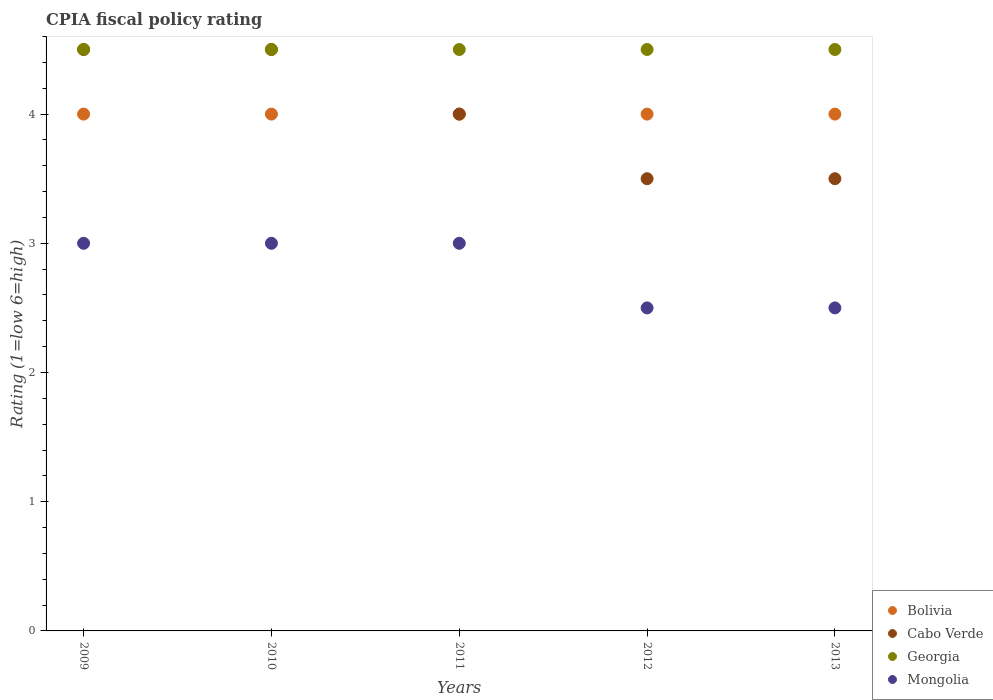How many different coloured dotlines are there?
Ensure brevity in your answer.  4. Is the number of dotlines equal to the number of legend labels?
Ensure brevity in your answer.  Yes. What is the CPIA rating in Cabo Verde in 2009?
Give a very brief answer. 4.5. Across all years, what is the minimum CPIA rating in Bolivia?
Provide a succinct answer. 4. What is the difference between the CPIA rating in Georgia in 2011 and that in 2012?
Make the answer very short. 0. What is the difference between the CPIA rating in Cabo Verde in 2010 and the CPIA rating in Bolivia in 2012?
Provide a short and direct response. 0.5. What is the average CPIA rating in Cabo Verde per year?
Keep it short and to the point. 4. What is the ratio of the CPIA rating in Georgia in 2009 to that in 2010?
Provide a short and direct response. 1. Is the sum of the CPIA rating in Bolivia in 2009 and 2013 greater than the maximum CPIA rating in Mongolia across all years?
Your answer should be very brief. Yes. Is it the case that in every year, the sum of the CPIA rating in Bolivia and CPIA rating in Georgia  is greater than the sum of CPIA rating in Mongolia and CPIA rating in Cabo Verde?
Ensure brevity in your answer.  Yes. Is it the case that in every year, the sum of the CPIA rating in Georgia and CPIA rating in Mongolia  is greater than the CPIA rating in Bolivia?
Provide a succinct answer. Yes. Is the CPIA rating in Mongolia strictly greater than the CPIA rating in Bolivia over the years?
Provide a succinct answer. No. How many years are there in the graph?
Offer a terse response. 5. What is the difference between two consecutive major ticks on the Y-axis?
Offer a terse response. 1. What is the title of the graph?
Keep it short and to the point. CPIA fiscal policy rating. What is the label or title of the X-axis?
Keep it short and to the point. Years. What is the Rating (1=low 6=high) of Cabo Verde in 2009?
Give a very brief answer. 4.5. What is the Rating (1=low 6=high) of Mongolia in 2009?
Ensure brevity in your answer.  3. What is the Rating (1=low 6=high) of Georgia in 2010?
Provide a short and direct response. 4.5. What is the Rating (1=low 6=high) in Mongolia in 2010?
Give a very brief answer. 3. What is the Rating (1=low 6=high) in Cabo Verde in 2011?
Offer a very short reply. 4. What is the Rating (1=low 6=high) of Georgia in 2011?
Make the answer very short. 4.5. What is the Rating (1=low 6=high) of Mongolia in 2012?
Your response must be concise. 2.5. Across all years, what is the maximum Rating (1=low 6=high) in Georgia?
Give a very brief answer. 4.5. Across all years, what is the maximum Rating (1=low 6=high) in Mongolia?
Make the answer very short. 3. Across all years, what is the minimum Rating (1=low 6=high) in Georgia?
Your answer should be very brief. 4.5. What is the total Rating (1=low 6=high) of Cabo Verde in the graph?
Your answer should be compact. 20. What is the total Rating (1=low 6=high) in Georgia in the graph?
Your answer should be very brief. 22.5. What is the difference between the Rating (1=low 6=high) of Bolivia in 2009 and that in 2010?
Make the answer very short. 0. What is the difference between the Rating (1=low 6=high) of Georgia in 2009 and that in 2010?
Offer a terse response. 0. What is the difference between the Rating (1=low 6=high) of Mongolia in 2009 and that in 2010?
Provide a succinct answer. 0. What is the difference between the Rating (1=low 6=high) in Georgia in 2009 and that in 2011?
Your answer should be compact. 0. What is the difference between the Rating (1=low 6=high) of Mongolia in 2009 and that in 2011?
Give a very brief answer. 0. What is the difference between the Rating (1=low 6=high) of Cabo Verde in 2009 and that in 2012?
Provide a short and direct response. 1. What is the difference between the Rating (1=low 6=high) of Bolivia in 2009 and that in 2013?
Offer a terse response. 0. What is the difference between the Rating (1=low 6=high) of Mongolia in 2009 and that in 2013?
Your answer should be compact. 0.5. What is the difference between the Rating (1=low 6=high) in Cabo Verde in 2010 and that in 2011?
Keep it short and to the point. 0.5. What is the difference between the Rating (1=low 6=high) in Mongolia in 2010 and that in 2011?
Offer a very short reply. 0. What is the difference between the Rating (1=low 6=high) of Bolivia in 2010 and that in 2012?
Ensure brevity in your answer.  0. What is the difference between the Rating (1=low 6=high) of Cabo Verde in 2010 and that in 2012?
Your answer should be very brief. 1. What is the difference between the Rating (1=low 6=high) in Georgia in 2010 and that in 2012?
Ensure brevity in your answer.  0. What is the difference between the Rating (1=low 6=high) in Georgia in 2010 and that in 2013?
Provide a succinct answer. 0. What is the difference between the Rating (1=low 6=high) of Georgia in 2011 and that in 2012?
Your answer should be compact. 0. What is the difference between the Rating (1=low 6=high) in Mongolia in 2011 and that in 2012?
Keep it short and to the point. 0.5. What is the difference between the Rating (1=low 6=high) in Bolivia in 2011 and that in 2013?
Give a very brief answer. 0. What is the difference between the Rating (1=low 6=high) in Cabo Verde in 2011 and that in 2013?
Offer a terse response. 0.5. What is the difference between the Rating (1=low 6=high) of Cabo Verde in 2012 and that in 2013?
Make the answer very short. 0. What is the difference between the Rating (1=low 6=high) of Cabo Verde in 2009 and the Rating (1=low 6=high) of Georgia in 2010?
Your answer should be very brief. 0. What is the difference between the Rating (1=low 6=high) in Cabo Verde in 2009 and the Rating (1=low 6=high) in Mongolia in 2010?
Offer a terse response. 1.5. What is the difference between the Rating (1=low 6=high) of Georgia in 2009 and the Rating (1=low 6=high) of Mongolia in 2010?
Provide a short and direct response. 1.5. What is the difference between the Rating (1=low 6=high) in Bolivia in 2009 and the Rating (1=low 6=high) in Cabo Verde in 2011?
Your answer should be compact. 0. What is the difference between the Rating (1=low 6=high) of Bolivia in 2009 and the Rating (1=low 6=high) of Georgia in 2011?
Ensure brevity in your answer.  -0.5. What is the difference between the Rating (1=low 6=high) in Cabo Verde in 2009 and the Rating (1=low 6=high) in Georgia in 2011?
Your answer should be compact. 0. What is the difference between the Rating (1=low 6=high) in Georgia in 2009 and the Rating (1=low 6=high) in Mongolia in 2011?
Offer a terse response. 1.5. What is the difference between the Rating (1=low 6=high) in Bolivia in 2009 and the Rating (1=low 6=high) in Georgia in 2012?
Your response must be concise. -0.5. What is the difference between the Rating (1=low 6=high) of Bolivia in 2009 and the Rating (1=low 6=high) of Mongolia in 2012?
Provide a short and direct response. 1.5. What is the difference between the Rating (1=low 6=high) of Cabo Verde in 2009 and the Rating (1=low 6=high) of Mongolia in 2012?
Your answer should be compact. 2. What is the difference between the Rating (1=low 6=high) of Bolivia in 2009 and the Rating (1=low 6=high) of Cabo Verde in 2013?
Provide a succinct answer. 0.5. What is the difference between the Rating (1=low 6=high) in Bolivia in 2009 and the Rating (1=low 6=high) in Georgia in 2013?
Offer a terse response. -0.5. What is the difference between the Rating (1=low 6=high) in Cabo Verde in 2009 and the Rating (1=low 6=high) in Georgia in 2013?
Your answer should be compact. 0. What is the difference between the Rating (1=low 6=high) in Bolivia in 2010 and the Rating (1=low 6=high) in Cabo Verde in 2011?
Ensure brevity in your answer.  0. What is the difference between the Rating (1=low 6=high) of Bolivia in 2010 and the Rating (1=low 6=high) of Georgia in 2011?
Keep it short and to the point. -0.5. What is the difference between the Rating (1=low 6=high) of Bolivia in 2010 and the Rating (1=low 6=high) of Mongolia in 2011?
Give a very brief answer. 1. What is the difference between the Rating (1=low 6=high) of Cabo Verde in 2010 and the Rating (1=low 6=high) of Georgia in 2011?
Ensure brevity in your answer.  0. What is the difference between the Rating (1=low 6=high) of Bolivia in 2010 and the Rating (1=low 6=high) of Cabo Verde in 2012?
Provide a short and direct response. 0.5. What is the difference between the Rating (1=low 6=high) in Bolivia in 2010 and the Rating (1=low 6=high) in Georgia in 2012?
Offer a terse response. -0.5. What is the difference between the Rating (1=low 6=high) of Cabo Verde in 2010 and the Rating (1=low 6=high) of Georgia in 2012?
Make the answer very short. 0. What is the difference between the Rating (1=low 6=high) in Cabo Verde in 2010 and the Rating (1=low 6=high) in Mongolia in 2012?
Your answer should be very brief. 2. What is the difference between the Rating (1=low 6=high) in Bolivia in 2010 and the Rating (1=low 6=high) in Cabo Verde in 2013?
Give a very brief answer. 0.5. What is the difference between the Rating (1=low 6=high) of Bolivia in 2010 and the Rating (1=low 6=high) of Georgia in 2013?
Make the answer very short. -0.5. What is the difference between the Rating (1=low 6=high) of Cabo Verde in 2010 and the Rating (1=low 6=high) of Georgia in 2013?
Your answer should be compact. 0. What is the difference between the Rating (1=low 6=high) in Georgia in 2010 and the Rating (1=low 6=high) in Mongolia in 2013?
Provide a succinct answer. 2. What is the difference between the Rating (1=low 6=high) in Bolivia in 2011 and the Rating (1=low 6=high) in Cabo Verde in 2012?
Offer a very short reply. 0.5. What is the difference between the Rating (1=low 6=high) in Bolivia in 2011 and the Rating (1=low 6=high) in Georgia in 2012?
Offer a very short reply. -0.5. What is the difference between the Rating (1=low 6=high) in Cabo Verde in 2011 and the Rating (1=low 6=high) in Georgia in 2012?
Provide a succinct answer. -0.5. What is the difference between the Rating (1=low 6=high) in Georgia in 2011 and the Rating (1=low 6=high) in Mongolia in 2013?
Make the answer very short. 2. What is the difference between the Rating (1=low 6=high) in Bolivia in 2012 and the Rating (1=low 6=high) in Georgia in 2013?
Your answer should be very brief. -0.5. What is the difference between the Rating (1=low 6=high) of Cabo Verde in 2012 and the Rating (1=low 6=high) of Georgia in 2013?
Offer a very short reply. -1. What is the difference between the Rating (1=low 6=high) in Georgia in 2012 and the Rating (1=low 6=high) in Mongolia in 2013?
Offer a very short reply. 2. What is the average Rating (1=low 6=high) in Bolivia per year?
Your answer should be very brief. 4. What is the average Rating (1=low 6=high) in Georgia per year?
Keep it short and to the point. 4.5. In the year 2009, what is the difference between the Rating (1=low 6=high) of Bolivia and Rating (1=low 6=high) of Mongolia?
Your response must be concise. 1. In the year 2009, what is the difference between the Rating (1=low 6=high) in Cabo Verde and Rating (1=low 6=high) in Mongolia?
Offer a terse response. 1.5. In the year 2009, what is the difference between the Rating (1=low 6=high) of Georgia and Rating (1=low 6=high) of Mongolia?
Provide a short and direct response. 1.5. In the year 2010, what is the difference between the Rating (1=low 6=high) of Bolivia and Rating (1=low 6=high) of Cabo Verde?
Make the answer very short. -0.5. In the year 2010, what is the difference between the Rating (1=low 6=high) in Bolivia and Rating (1=low 6=high) in Georgia?
Your response must be concise. -0.5. In the year 2010, what is the difference between the Rating (1=low 6=high) in Cabo Verde and Rating (1=low 6=high) in Mongolia?
Provide a succinct answer. 1.5. In the year 2011, what is the difference between the Rating (1=low 6=high) of Bolivia and Rating (1=low 6=high) of Cabo Verde?
Provide a short and direct response. 0. In the year 2011, what is the difference between the Rating (1=low 6=high) of Bolivia and Rating (1=low 6=high) of Georgia?
Ensure brevity in your answer.  -0.5. In the year 2011, what is the difference between the Rating (1=low 6=high) of Bolivia and Rating (1=low 6=high) of Mongolia?
Make the answer very short. 1. In the year 2011, what is the difference between the Rating (1=low 6=high) in Cabo Verde and Rating (1=low 6=high) in Georgia?
Your answer should be very brief. -0.5. In the year 2012, what is the difference between the Rating (1=low 6=high) of Bolivia and Rating (1=low 6=high) of Cabo Verde?
Give a very brief answer. 0.5. In the year 2012, what is the difference between the Rating (1=low 6=high) in Cabo Verde and Rating (1=low 6=high) in Mongolia?
Offer a very short reply. 1. In the year 2012, what is the difference between the Rating (1=low 6=high) of Georgia and Rating (1=low 6=high) of Mongolia?
Keep it short and to the point. 2. In the year 2013, what is the difference between the Rating (1=low 6=high) in Bolivia and Rating (1=low 6=high) in Cabo Verde?
Your response must be concise. 0.5. In the year 2013, what is the difference between the Rating (1=low 6=high) in Georgia and Rating (1=low 6=high) in Mongolia?
Keep it short and to the point. 2. What is the ratio of the Rating (1=low 6=high) in Georgia in 2009 to that in 2010?
Your response must be concise. 1. What is the ratio of the Rating (1=low 6=high) in Cabo Verde in 2009 to that in 2011?
Make the answer very short. 1.12. What is the ratio of the Rating (1=low 6=high) of Mongolia in 2009 to that in 2011?
Offer a very short reply. 1. What is the ratio of the Rating (1=low 6=high) of Georgia in 2009 to that in 2012?
Provide a short and direct response. 1. What is the ratio of the Rating (1=low 6=high) in Georgia in 2010 to that in 2011?
Keep it short and to the point. 1. What is the ratio of the Rating (1=low 6=high) of Mongolia in 2010 to that in 2011?
Give a very brief answer. 1. What is the ratio of the Rating (1=low 6=high) in Bolivia in 2010 to that in 2012?
Ensure brevity in your answer.  1. What is the ratio of the Rating (1=low 6=high) in Georgia in 2010 to that in 2012?
Your answer should be very brief. 1. What is the ratio of the Rating (1=low 6=high) in Cabo Verde in 2010 to that in 2013?
Your response must be concise. 1.29. What is the ratio of the Rating (1=low 6=high) of Georgia in 2010 to that in 2013?
Ensure brevity in your answer.  1. What is the ratio of the Rating (1=low 6=high) of Bolivia in 2011 to that in 2012?
Your response must be concise. 1. What is the ratio of the Rating (1=low 6=high) of Mongolia in 2011 to that in 2012?
Keep it short and to the point. 1.2. What is the ratio of the Rating (1=low 6=high) in Cabo Verde in 2011 to that in 2013?
Ensure brevity in your answer.  1.14. What is the ratio of the Rating (1=low 6=high) of Bolivia in 2012 to that in 2013?
Offer a very short reply. 1. What is the ratio of the Rating (1=low 6=high) in Cabo Verde in 2012 to that in 2013?
Your answer should be compact. 1. What is the difference between the highest and the second highest Rating (1=low 6=high) of Bolivia?
Provide a succinct answer. 0. What is the difference between the highest and the lowest Rating (1=low 6=high) in Georgia?
Your answer should be compact. 0. What is the difference between the highest and the lowest Rating (1=low 6=high) in Mongolia?
Your answer should be very brief. 0.5. 